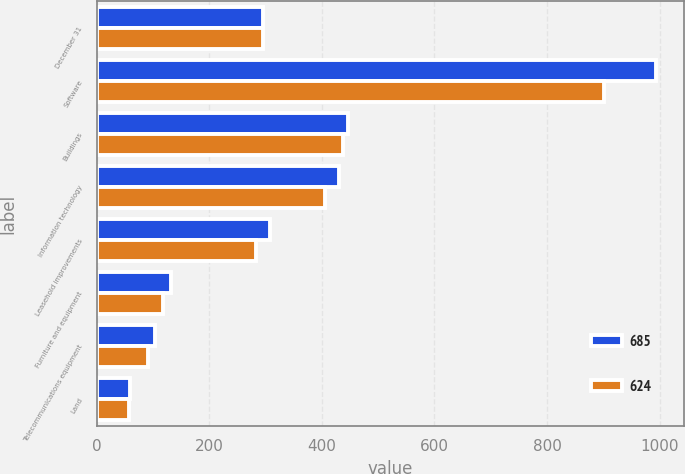Convert chart. <chart><loc_0><loc_0><loc_500><loc_500><stacked_bar_chart><ecel><fcel>December 31<fcel>Software<fcel>Buildings<fcel>Information technology<fcel>Leasehold improvements<fcel>Furniture and equipment<fcel>Telecommunications equipment<fcel>Land<nl><fcel>685<fcel>294.5<fcel>993<fcel>446<fcel>430<fcel>307<fcel>131<fcel>104<fcel>59<nl><fcel>624<fcel>294.5<fcel>902<fcel>438<fcel>405<fcel>282<fcel>118<fcel>91<fcel>57<nl></chart> 